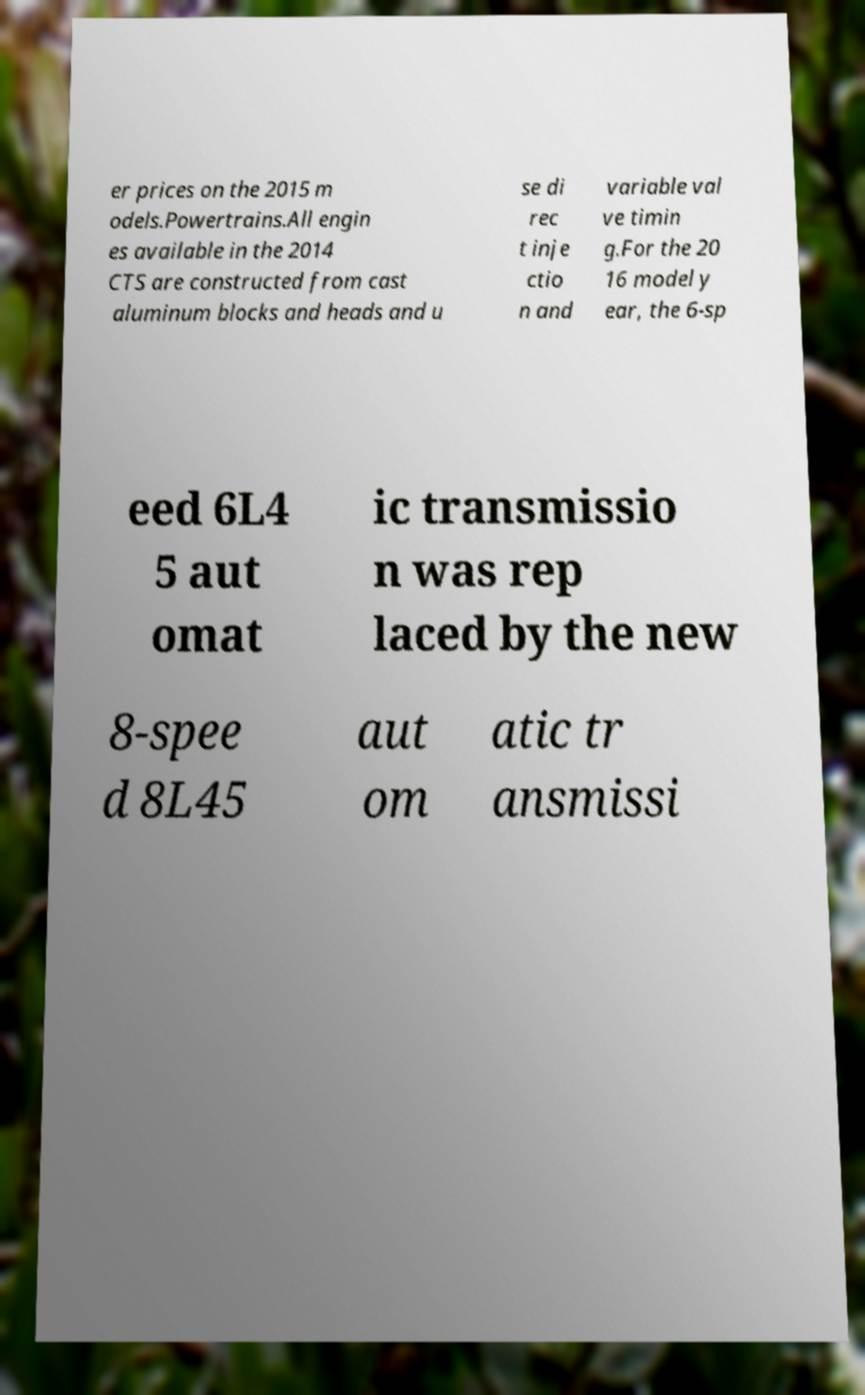For documentation purposes, I need the text within this image transcribed. Could you provide that? er prices on the 2015 m odels.Powertrains.All engin es available in the 2014 CTS are constructed from cast aluminum blocks and heads and u se di rec t inje ctio n and variable val ve timin g.For the 20 16 model y ear, the 6-sp eed 6L4 5 aut omat ic transmissio n was rep laced by the new 8-spee d 8L45 aut om atic tr ansmissi 